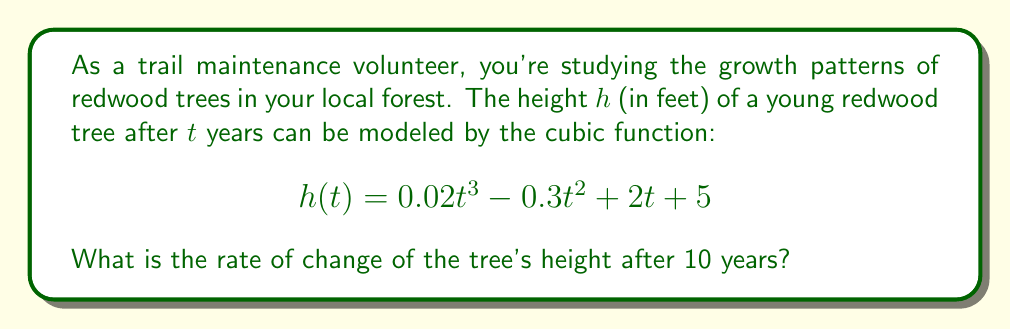What is the answer to this math problem? To find the rate of change of the tree's height after 10 years, we need to calculate the derivative of the given function and evaluate it at $t = 10$. Here's the step-by-step process:

1) First, let's find the derivative of $h(t)$:
   $$h(t) = 0.02t^3 - 0.3t^2 + 2t + 5$$
   $$h'(t) = 0.06t^2 - 0.6t + 2$$

2) The derivative $h'(t)$ represents the instantaneous rate of change of the tree's height.

3) Now, we need to evaluate $h'(t)$ at $t = 10$:
   $$h'(10) = 0.06(10)^2 - 0.6(10) + 2$$
   $$= 0.06(100) - 6 + 2$$
   $$= 6 - 6 + 2$$
   $$= 2$$

4) Therefore, the rate of change of the tree's height after 10 years is 2 feet per year.
Answer: 2 feet per year 